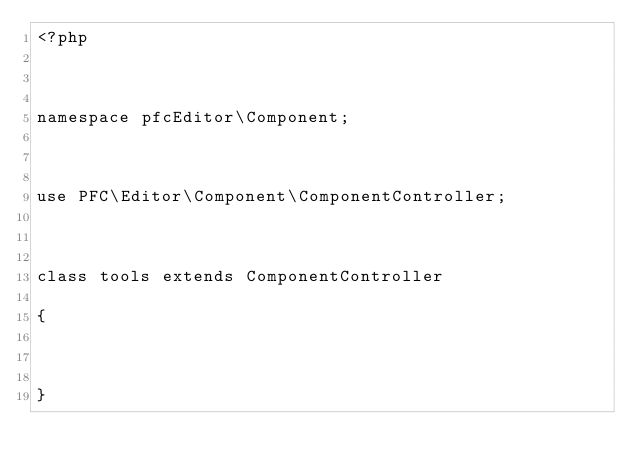<code> <loc_0><loc_0><loc_500><loc_500><_PHP_><?php 

namespace pfcEditor\Component;

use PFC\Editor\Component\ComponentController;

class tools extends ComponentController
{
    
}</code> 